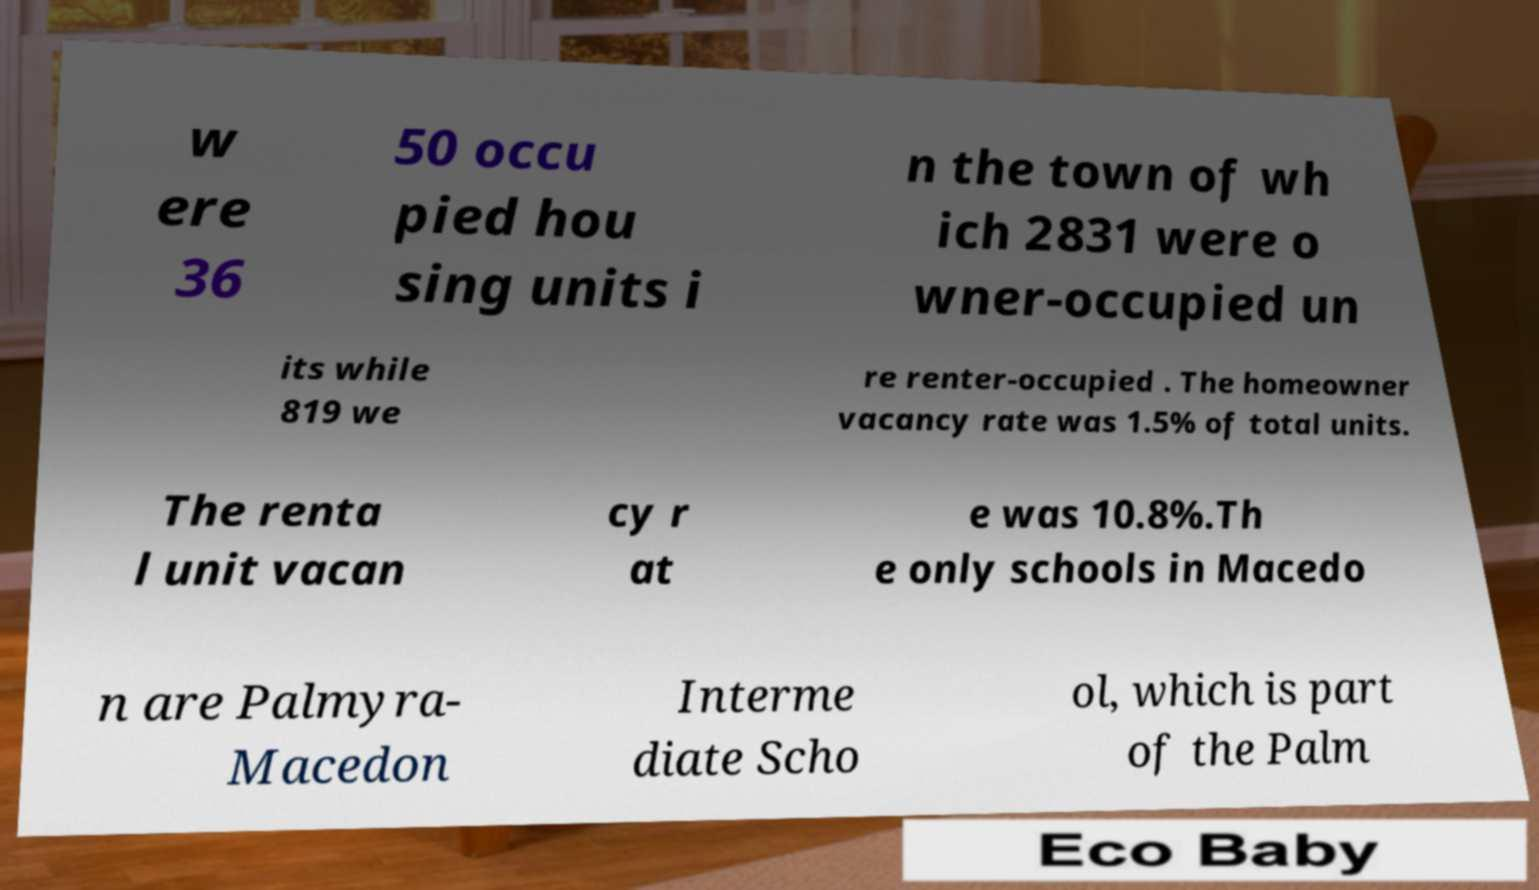What messages or text are displayed in this image? I need them in a readable, typed format. w ere 36 50 occu pied hou sing units i n the town of wh ich 2831 were o wner-occupied un its while 819 we re renter-occupied . The homeowner vacancy rate was 1.5% of total units. The renta l unit vacan cy r at e was 10.8%.Th e only schools in Macedo n are Palmyra- Macedon Interme diate Scho ol, which is part of the Palm 